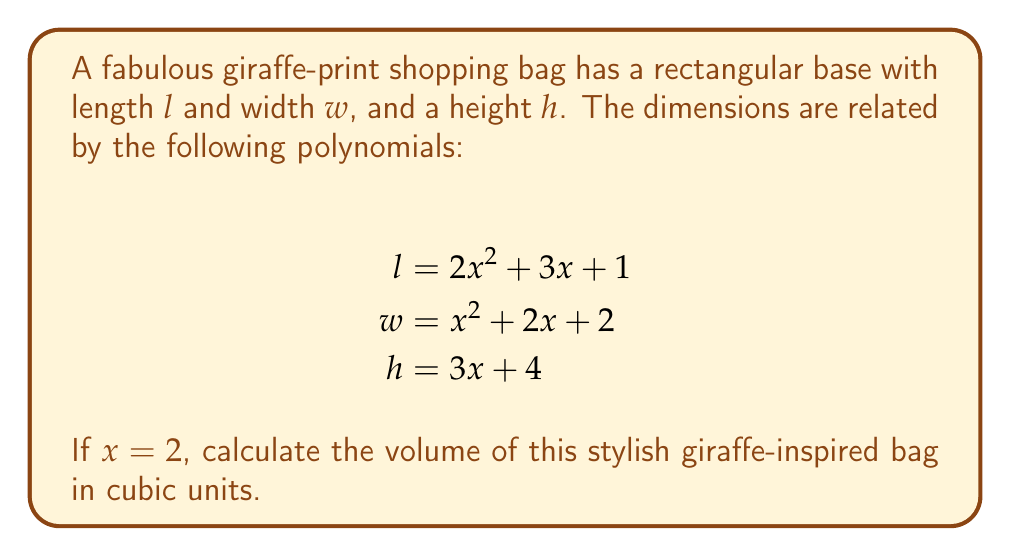What is the answer to this math problem? Let's approach this step-by-step:

1) First, we need to calculate the dimensions of the bag when $x = 2$:

   For length $l$:
   $$l = 2x^2 + 3x + 1$$
   $$l = 2(2^2) + 3(2) + 1$$
   $$l = 2(4) + 6 + 1 = 8 + 6 + 1 = 15$$

   For width $w$:
   $$w = x^2 + 2x + 2$$
   $$w = 2^2 + 2(2) + 2$$
   $$w = 4 + 4 + 2 = 10$$

   For height $h$:
   $$h = 3x + 4$$
   $$h = 3(2) + 4$$
   $$h = 6 + 4 = 10$$

2) Now that we have the dimensions, we can calculate the volume. The volume of a rectangular prism is given by the formula:

   $$V = l \times w \times h$$

3) Substituting our calculated values:

   $$V = 15 \times 10 \times 10$$

4) Multiplying these numbers:

   $$V = 1500$$

Thus, the volume of the giraffe-print shopping bag is 1500 cubic units.
Answer: 1500 cubic units 